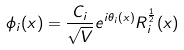<formula> <loc_0><loc_0><loc_500><loc_500>\phi _ { i } ( { x } ) = \frac { C _ { i } } { \sqrt { V } } e ^ { i \theta _ { i } ( { x } ) } R _ { i } ^ { \frac { 1 } { 2 } } ( { x } )</formula> 